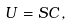<formula> <loc_0><loc_0><loc_500><loc_500>U = S C \, ,</formula> 